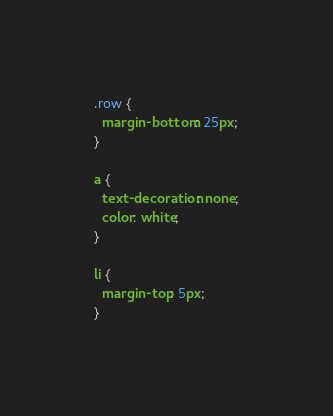<code> <loc_0><loc_0><loc_500><loc_500><_CSS_>.row {
  margin-bottom: 25px;
}

a {
  text-decoration: none;
  color: white;
}

li {
  margin-top: 5px;
}
</code> 